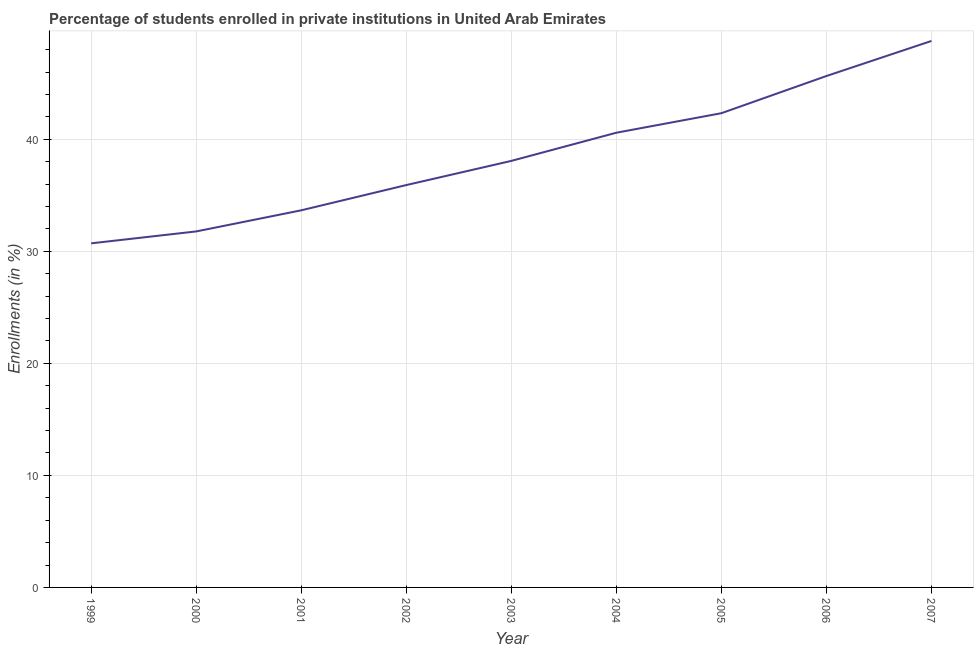What is the enrollments in private institutions in 2007?
Make the answer very short. 48.78. Across all years, what is the maximum enrollments in private institutions?
Give a very brief answer. 48.78. Across all years, what is the minimum enrollments in private institutions?
Your answer should be very brief. 30.71. In which year was the enrollments in private institutions maximum?
Make the answer very short. 2007. What is the sum of the enrollments in private institutions?
Your answer should be very brief. 347.48. What is the difference between the enrollments in private institutions in 2002 and 2005?
Offer a very short reply. -6.42. What is the average enrollments in private institutions per year?
Ensure brevity in your answer.  38.61. What is the median enrollments in private institutions?
Offer a very short reply. 38.07. In how many years, is the enrollments in private institutions greater than 12 %?
Provide a short and direct response. 9. What is the ratio of the enrollments in private institutions in 2000 to that in 2004?
Ensure brevity in your answer.  0.78. Is the enrollments in private institutions in 2004 less than that in 2007?
Give a very brief answer. Yes. Is the difference between the enrollments in private institutions in 2006 and 2007 greater than the difference between any two years?
Ensure brevity in your answer.  No. What is the difference between the highest and the second highest enrollments in private institutions?
Ensure brevity in your answer.  3.13. Is the sum of the enrollments in private institutions in 2003 and 2005 greater than the maximum enrollments in private institutions across all years?
Provide a succinct answer. Yes. What is the difference between the highest and the lowest enrollments in private institutions?
Offer a terse response. 18.07. In how many years, is the enrollments in private institutions greater than the average enrollments in private institutions taken over all years?
Offer a terse response. 4. Does the enrollments in private institutions monotonically increase over the years?
Your answer should be very brief. Yes. How many years are there in the graph?
Your answer should be compact. 9. What is the difference between two consecutive major ticks on the Y-axis?
Your answer should be very brief. 10. Does the graph contain any zero values?
Your answer should be very brief. No. Does the graph contain grids?
Ensure brevity in your answer.  Yes. What is the title of the graph?
Keep it short and to the point. Percentage of students enrolled in private institutions in United Arab Emirates. What is the label or title of the Y-axis?
Make the answer very short. Enrollments (in %). What is the Enrollments (in %) of 1999?
Provide a short and direct response. 30.71. What is the Enrollments (in %) in 2000?
Provide a succinct answer. 31.78. What is the Enrollments (in %) of 2001?
Your response must be concise. 33.66. What is the Enrollments (in %) in 2002?
Your answer should be compact. 35.91. What is the Enrollments (in %) in 2003?
Your answer should be compact. 38.07. What is the Enrollments (in %) in 2004?
Provide a short and direct response. 40.59. What is the Enrollments (in %) of 2005?
Your answer should be very brief. 42.33. What is the Enrollments (in %) of 2006?
Offer a terse response. 45.65. What is the Enrollments (in %) of 2007?
Ensure brevity in your answer.  48.78. What is the difference between the Enrollments (in %) in 1999 and 2000?
Ensure brevity in your answer.  -1.06. What is the difference between the Enrollments (in %) in 1999 and 2001?
Give a very brief answer. -2.95. What is the difference between the Enrollments (in %) in 1999 and 2002?
Your answer should be very brief. -5.2. What is the difference between the Enrollments (in %) in 1999 and 2003?
Provide a short and direct response. -7.36. What is the difference between the Enrollments (in %) in 1999 and 2004?
Provide a succinct answer. -9.87. What is the difference between the Enrollments (in %) in 1999 and 2005?
Your answer should be compact. -11.62. What is the difference between the Enrollments (in %) in 1999 and 2006?
Your response must be concise. -14.94. What is the difference between the Enrollments (in %) in 1999 and 2007?
Give a very brief answer. -18.07. What is the difference between the Enrollments (in %) in 2000 and 2001?
Give a very brief answer. -1.88. What is the difference between the Enrollments (in %) in 2000 and 2002?
Your answer should be very brief. -4.14. What is the difference between the Enrollments (in %) in 2000 and 2003?
Ensure brevity in your answer.  -6.3. What is the difference between the Enrollments (in %) in 2000 and 2004?
Provide a succinct answer. -8.81. What is the difference between the Enrollments (in %) in 2000 and 2005?
Ensure brevity in your answer.  -10.55. What is the difference between the Enrollments (in %) in 2000 and 2006?
Your answer should be compact. -13.87. What is the difference between the Enrollments (in %) in 2000 and 2007?
Make the answer very short. -17. What is the difference between the Enrollments (in %) in 2001 and 2002?
Offer a terse response. -2.25. What is the difference between the Enrollments (in %) in 2001 and 2003?
Give a very brief answer. -4.41. What is the difference between the Enrollments (in %) in 2001 and 2004?
Provide a succinct answer. -6.93. What is the difference between the Enrollments (in %) in 2001 and 2005?
Your answer should be compact. -8.67. What is the difference between the Enrollments (in %) in 2001 and 2006?
Make the answer very short. -11.99. What is the difference between the Enrollments (in %) in 2001 and 2007?
Provide a succinct answer. -15.12. What is the difference between the Enrollments (in %) in 2002 and 2003?
Ensure brevity in your answer.  -2.16. What is the difference between the Enrollments (in %) in 2002 and 2004?
Your answer should be very brief. -4.67. What is the difference between the Enrollments (in %) in 2002 and 2005?
Give a very brief answer. -6.42. What is the difference between the Enrollments (in %) in 2002 and 2006?
Make the answer very short. -9.73. What is the difference between the Enrollments (in %) in 2002 and 2007?
Your response must be concise. -12.86. What is the difference between the Enrollments (in %) in 2003 and 2004?
Your response must be concise. -2.52. What is the difference between the Enrollments (in %) in 2003 and 2005?
Provide a succinct answer. -4.26. What is the difference between the Enrollments (in %) in 2003 and 2006?
Your answer should be compact. -7.58. What is the difference between the Enrollments (in %) in 2003 and 2007?
Your answer should be compact. -10.71. What is the difference between the Enrollments (in %) in 2004 and 2005?
Your response must be concise. -1.74. What is the difference between the Enrollments (in %) in 2004 and 2006?
Your response must be concise. -5.06. What is the difference between the Enrollments (in %) in 2004 and 2007?
Offer a terse response. -8.19. What is the difference between the Enrollments (in %) in 2005 and 2006?
Give a very brief answer. -3.32. What is the difference between the Enrollments (in %) in 2005 and 2007?
Give a very brief answer. -6.45. What is the difference between the Enrollments (in %) in 2006 and 2007?
Keep it short and to the point. -3.13. What is the ratio of the Enrollments (in %) in 1999 to that in 2001?
Provide a succinct answer. 0.91. What is the ratio of the Enrollments (in %) in 1999 to that in 2002?
Offer a terse response. 0.85. What is the ratio of the Enrollments (in %) in 1999 to that in 2003?
Provide a succinct answer. 0.81. What is the ratio of the Enrollments (in %) in 1999 to that in 2004?
Provide a succinct answer. 0.76. What is the ratio of the Enrollments (in %) in 1999 to that in 2005?
Offer a very short reply. 0.73. What is the ratio of the Enrollments (in %) in 1999 to that in 2006?
Provide a succinct answer. 0.67. What is the ratio of the Enrollments (in %) in 1999 to that in 2007?
Offer a terse response. 0.63. What is the ratio of the Enrollments (in %) in 2000 to that in 2001?
Ensure brevity in your answer.  0.94. What is the ratio of the Enrollments (in %) in 2000 to that in 2002?
Make the answer very short. 0.89. What is the ratio of the Enrollments (in %) in 2000 to that in 2003?
Your response must be concise. 0.83. What is the ratio of the Enrollments (in %) in 2000 to that in 2004?
Your answer should be very brief. 0.78. What is the ratio of the Enrollments (in %) in 2000 to that in 2005?
Give a very brief answer. 0.75. What is the ratio of the Enrollments (in %) in 2000 to that in 2006?
Make the answer very short. 0.7. What is the ratio of the Enrollments (in %) in 2000 to that in 2007?
Offer a very short reply. 0.65. What is the ratio of the Enrollments (in %) in 2001 to that in 2002?
Ensure brevity in your answer.  0.94. What is the ratio of the Enrollments (in %) in 2001 to that in 2003?
Provide a short and direct response. 0.88. What is the ratio of the Enrollments (in %) in 2001 to that in 2004?
Provide a short and direct response. 0.83. What is the ratio of the Enrollments (in %) in 2001 to that in 2005?
Provide a succinct answer. 0.8. What is the ratio of the Enrollments (in %) in 2001 to that in 2006?
Offer a terse response. 0.74. What is the ratio of the Enrollments (in %) in 2001 to that in 2007?
Offer a terse response. 0.69. What is the ratio of the Enrollments (in %) in 2002 to that in 2003?
Your answer should be compact. 0.94. What is the ratio of the Enrollments (in %) in 2002 to that in 2004?
Your answer should be very brief. 0.89. What is the ratio of the Enrollments (in %) in 2002 to that in 2005?
Ensure brevity in your answer.  0.85. What is the ratio of the Enrollments (in %) in 2002 to that in 2006?
Your answer should be very brief. 0.79. What is the ratio of the Enrollments (in %) in 2002 to that in 2007?
Provide a short and direct response. 0.74. What is the ratio of the Enrollments (in %) in 2003 to that in 2004?
Your answer should be compact. 0.94. What is the ratio of the Enrollments (in %) in 2003 to that in 2005?
Offer a terse response. 0.9. What is the ratio of the Enrollments (in %) in 2003 to that in 2006?
Provide a short and direct response. 0.83. What is the ratio of the Enrollments (in %) in 2003 to that in 2007?
Ensure brevity in your answer.  0.78. What is the ratio of the Enrollments (in %) in 2004 to that in 2006?
Your answer should be compact. 0.89. What is the ratio of the Enrollments (in %) in 2004 to that in 2007?
Offer a terse response. 0.83. What is the ratio of the Enrollments (in %) in 2005 to that in 2006?
Your answer should be very brief. 0.93. What is the ratio of the Enrollments (in %) in 2005 to that in 2007?
Your answer should be very brief. 0.87. What is the ratio of the Enrollments (in %) in 2006 to that in 2007?
Offer a terse response. 0.94. 